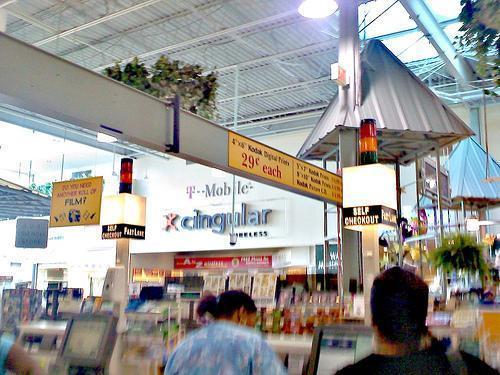How many people are wearing blue shirt?
Give a very brief answer. 1. 